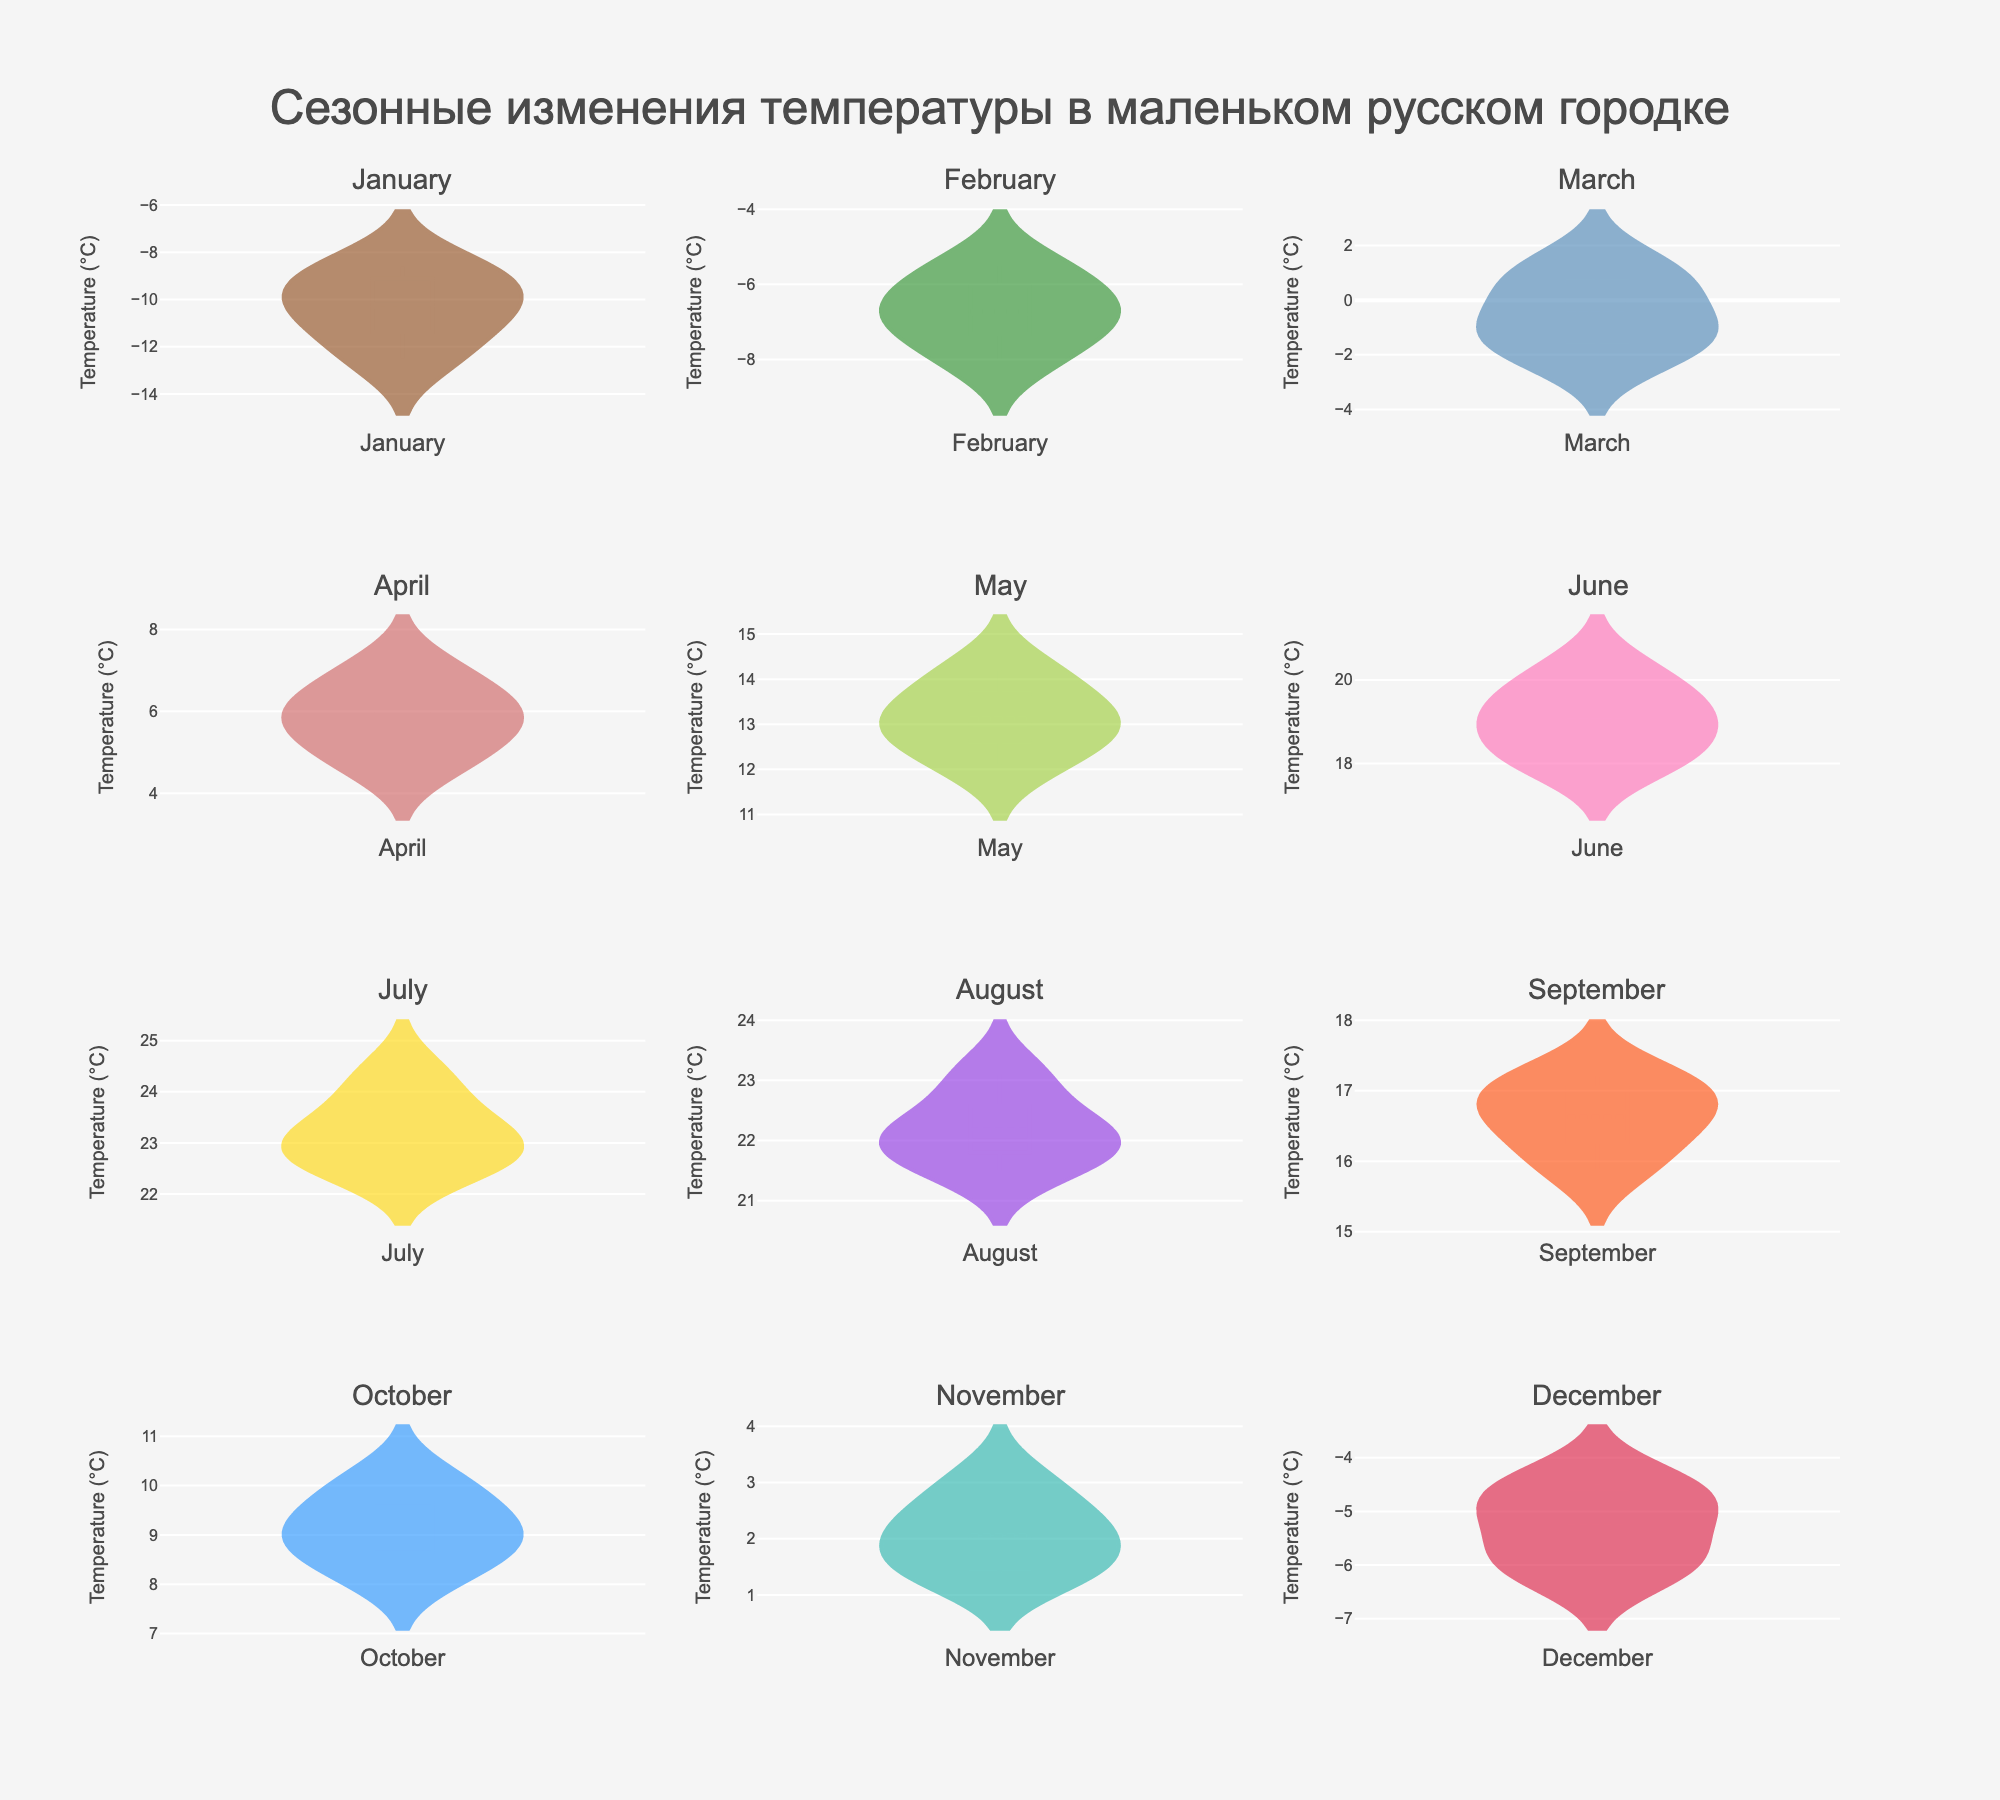What is the title of the subplot figure? The title of the figure is displayed at the top of the plot in larger and bold font. It provides a summary of what the figure is about.
Answer: Сезонные изменения температуры в маленьком русском городке How many subplots are there in total? The figure contains subplots arranged in a grid layout. By observing the number of rows and columns, we see there are 4 rows and 3 columns, making a total of 12 subplots.
Answer: 12 What month has the highest average temperature based on the density plot? By observing the density plots, we can see the centroid of the temperature distribution for each month. The subplot for July has the highest temperatures with values around 22-24°C.
Answer: July Which month shows the largest temperature variation? To determine variation, we look at the spread of the density plots. January shows a wide spread from around -13°C to -8°C, which indicates a large variation.
Answer: January Compare the variation in temperatures between February and November. Which one shows a greater spread? By observing the density plots, February's temperatures range approximately from -8.0°C to -5.5°C, while November's temperatures range from around 1.4°C to 3.0°C. February shows a slightly greater spread.
Answer: February What is the predominant color for the March temperature plot? Each subplot uses a unique color. For March, the predominant color is observed to be a blue-like color.
Answer: Blue Which month has the coldest average temperature? The subplot representing January shows the coldest average temperatures, concentrated around -10°C.
Answer: January Are there more months where the average temperature is above or below freezing? By glancing at the density plots, we can count the number of subplots with temperature distributions above or below 0°C. Months with above freezing: May, June, July, August, September, October, and months with below freezing: January, February, March, November, December. There are more months with above freezing temperatures.
Answer: Above freezing Explain the temperature pattern observed through the months from January to December. Observing the density plots, January and February show very cold temperatures, followed by a gradual increase in March and April. Temperatures peak in July with the highest values, then gradually decrease towards December. This indicates a typical seasonal temperature pattern where it's cold in winter months and warm in summer months.
Answer: Gradual increase from winter to summer, peaking in summer, then decreasing towards winter What is the average temperature in June based on the density plot? Observing the density plot for June, the average temperature is centered around values between 18°C and 20°C. The line indicating the mean value can be used to determine this more precisely.
Answer: 19°C 